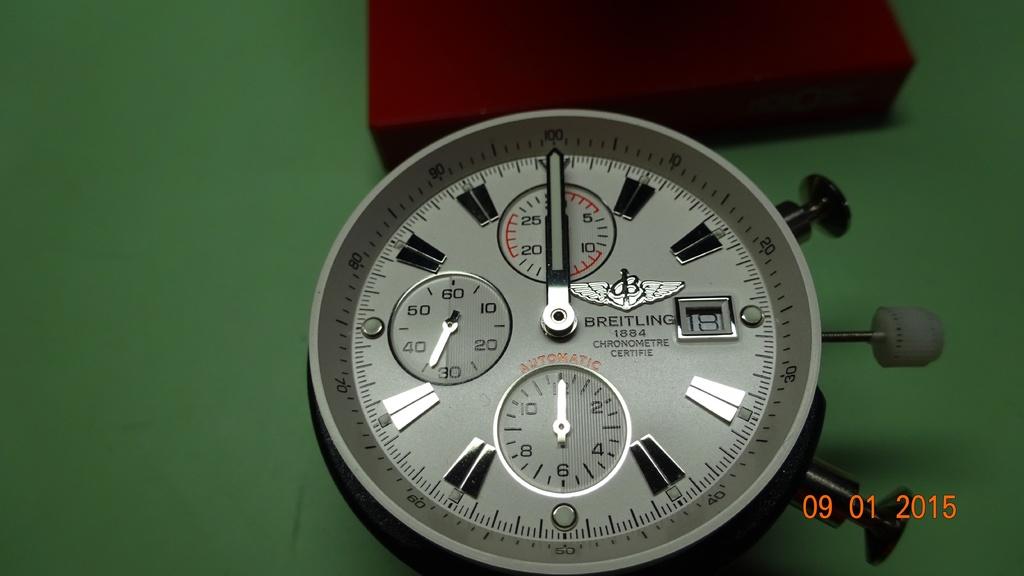What time is displayed on the watch?
Ensure brevity in your answer.  12:00. When was this photo taken?
Offer a very short reply. 09/01/2015. 